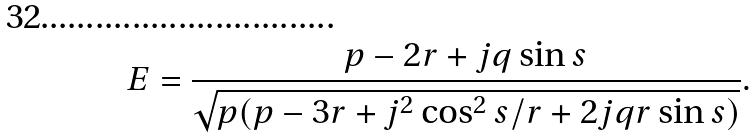<formula> <loc_0><loc_0><loc_500><loc_500>E = \frac { p - 2 r + j q \sin { s } } { \sqrt { p ( p - 3 r + j ^ { 2 } \cos ^ { 2 } { s } / r + 2 j q r \sin { s } ) } } .</formula> 